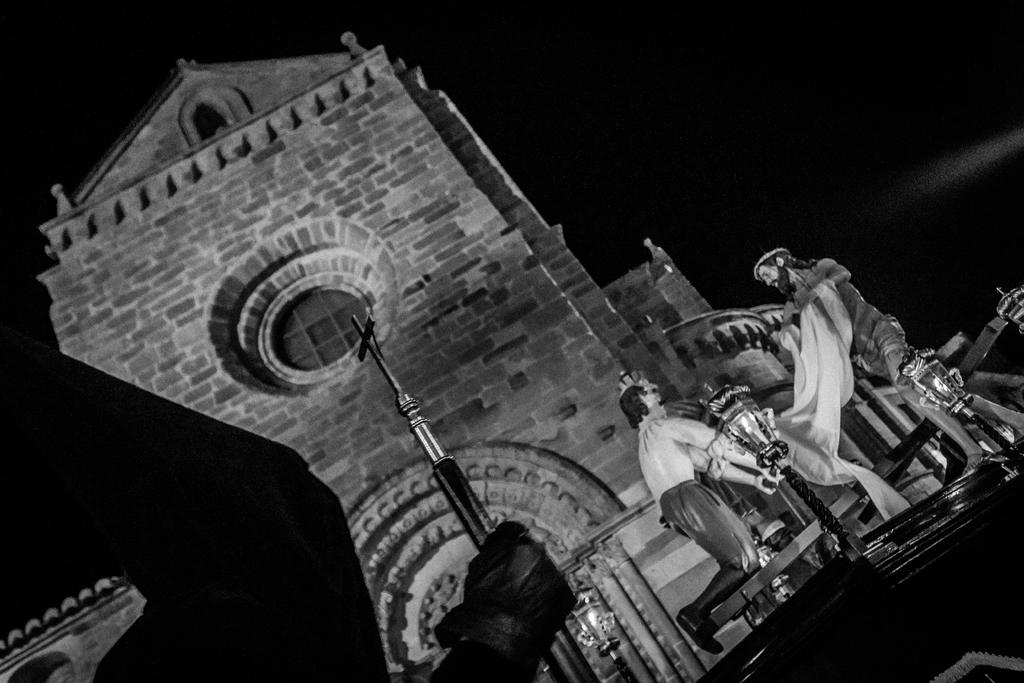What is the color scheme of the image? The image is black and white. What type of building is shown in the image? The image shows the outside view of a church. Are there any people or figures in the image? Yes, there are depictions of persons in the image. What else can be seen in the image besides the church and people? Lights are visible in the image. Can you hear the sound of a whistle in the image? There is no sound in the image, and therefore no whistle can be heard. Is there any paper visible in the image? There is no paper visible in the image. 